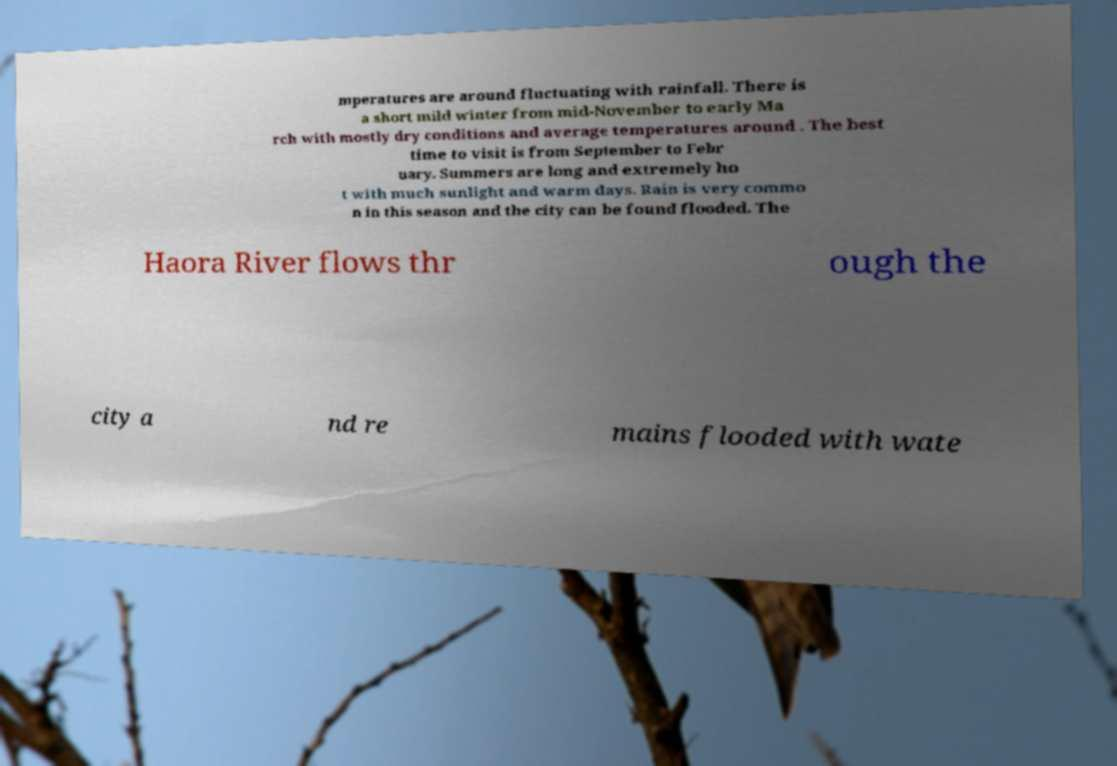For documentation purposes, I need the text within this image transcribed. Could you provide that? mperatures are around fluctuating with rainfall. There is a short mild winter from mid-November to early Ma rch with mostly dry conditions and average temperatures around . The best time to visit is from September to Febr uary. Summers are long and extremely ho t with much sunlight and warm days. Rain is very commo n in this season and the city can be found flooded. The Haora River flows thr ough the city a nd re mains flooded with wate 